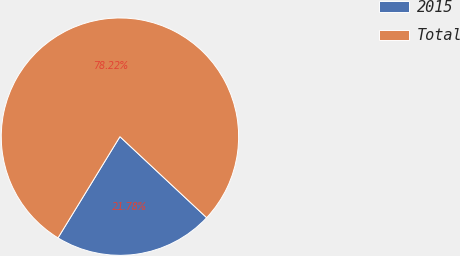Convert chart. <chart><loc_0><loc_0><loc_500><loc_500><pie_chart><fcel>2015<fcel>Total<nl><fcel>21.78%<fcel>78.22%<nl></chart> 